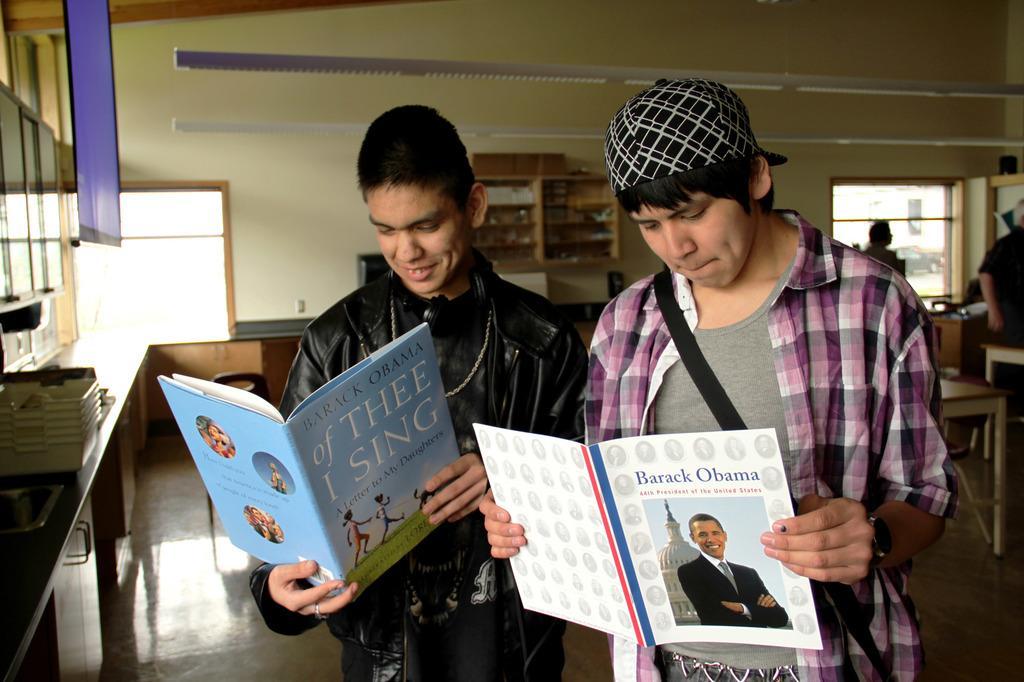Please provide a concise description of this image. In the foreground of this image, there are two men standing and holding books. In the background, there are few trays on the slab, a blue color cloth at the top and we can also see cupboards, windows, shelf, table, few objects and two people on the right. 